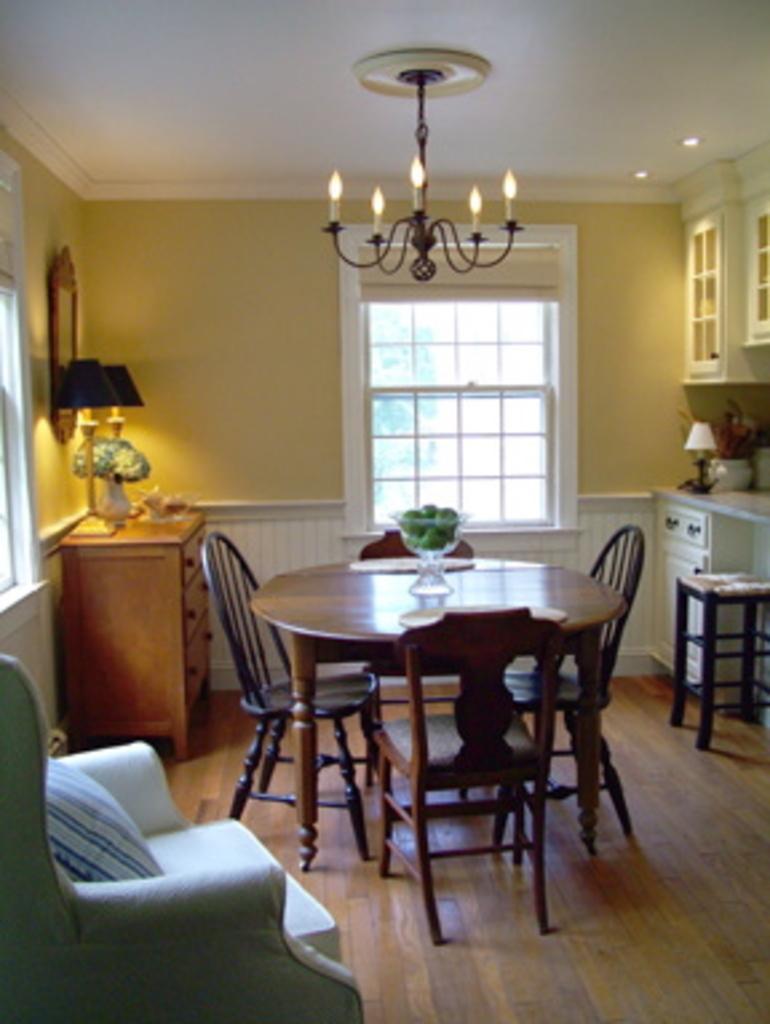Please provide a concise description of this image. In this image there are chairs and tables. Left side there is a chair having a cushion. Beside there is a table having lamps and a flower vase. There are chairs surrounded by the table having a bowl. Right side there is a stool. Behind there is a cabinet having lamps and a pot. The Pot is having a plant. There are cupboards attached to the wall having windows. Top of the image there is a chandelier hanging from the roof. Left side there is a frame attached to the wall. 